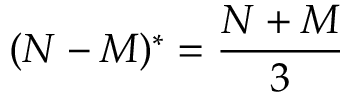<formula> <loc_0><loc_0><loc_500><loc_500>( N - M ) ^ { * } = \frac { N + M } { 3 }</formula> 